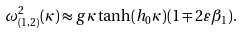<formula> <loc_0><loc_0><loc_500><loc_500>\omega ^ { 2 } _ { ( 1 , 2 ) } ( \kappa ) \approx g \kappa \tanh ( h _ { 0 } \kappa ) ( 1 \mp 2 \varepsilon \beta _ { 1 } ) .</formula> 